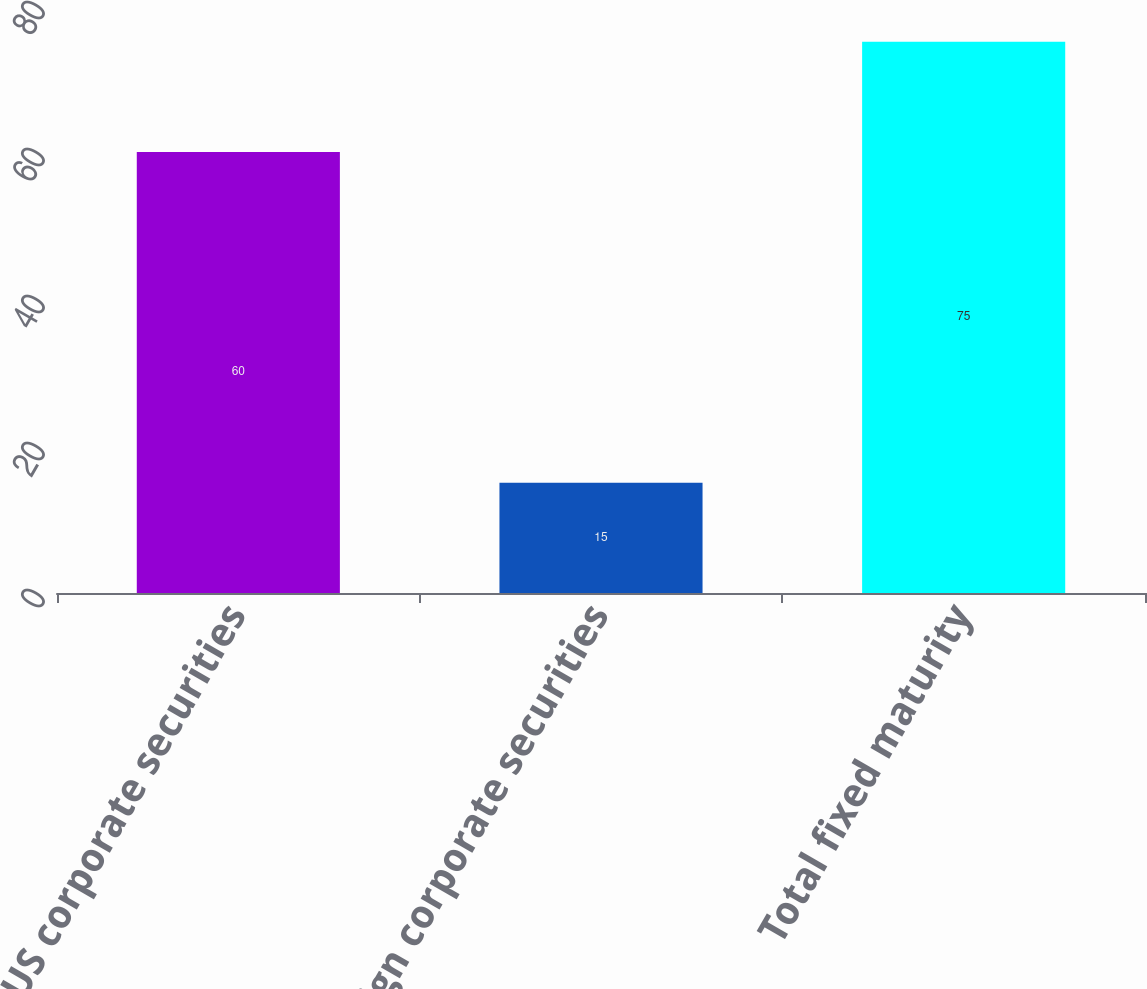<chart> <loc_0><loc_0><loc_500><loc_500><bar_chart><fcel>US corporate securities<fcel>Foreign corporate securities<fcel>Total fixed maturity<nl><fcel>60<fcel>15<fcel>75<nl></chart> 